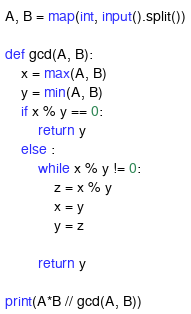Convert code to text. <code><loc_0><loc_0><loc_500><loc_500><_Python_>A, B = map(int, input().split())

def gcd(A, B):
    x = max(A, B)
    y = min(A, B)
    if x % y == 0:
        return y
    else : 
        while x % y != 0:
            z = x % y
            x = y
            y = z
        
        return y

print(A*B // gcd(A, B))


</code> 